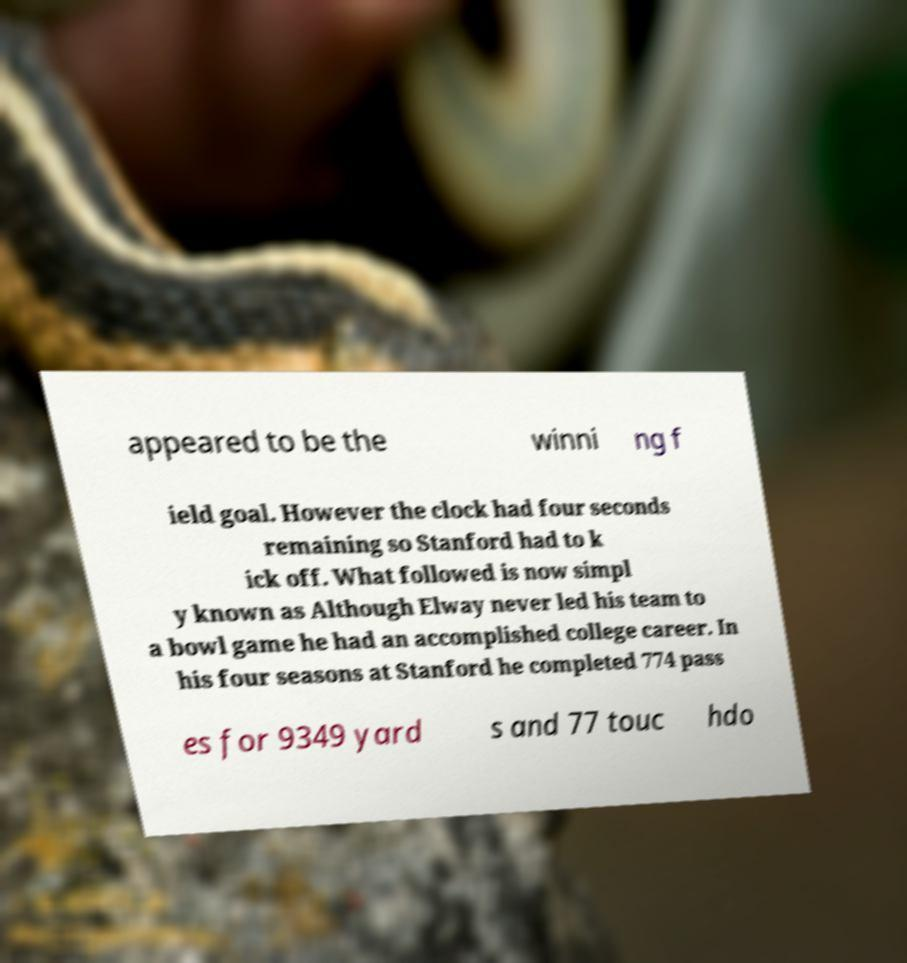Please read and relay the text visible in this image. What does it say? appeared to be the winni ng f ield goal. However the clock had four seconds remaining so Stanford had to k ick off. What followed is now simpl y known as Although Elway never led his team to a bowl game he had an accomplished college career. In his four seasons at Stanford he completed 774 pass es for 9349 yard s and 77 touc hdo 